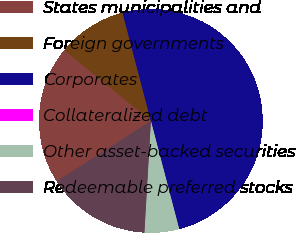<chart> <loc_0><loc_0><loc_500><loc_500><pie_chart><fcel>States municipalities and<fcel>Foreign governments<fcel>Corporates<fcel>Collateralized debt<fcel>Other asset-backed securities<fcel>Redeemable preferred stocks<nl><fcel>20.0%<fcel>10.0%<fcel>50.0%<fcel>0.0%<fcel>5.0%<fcel>15.0%<nl></chart> 